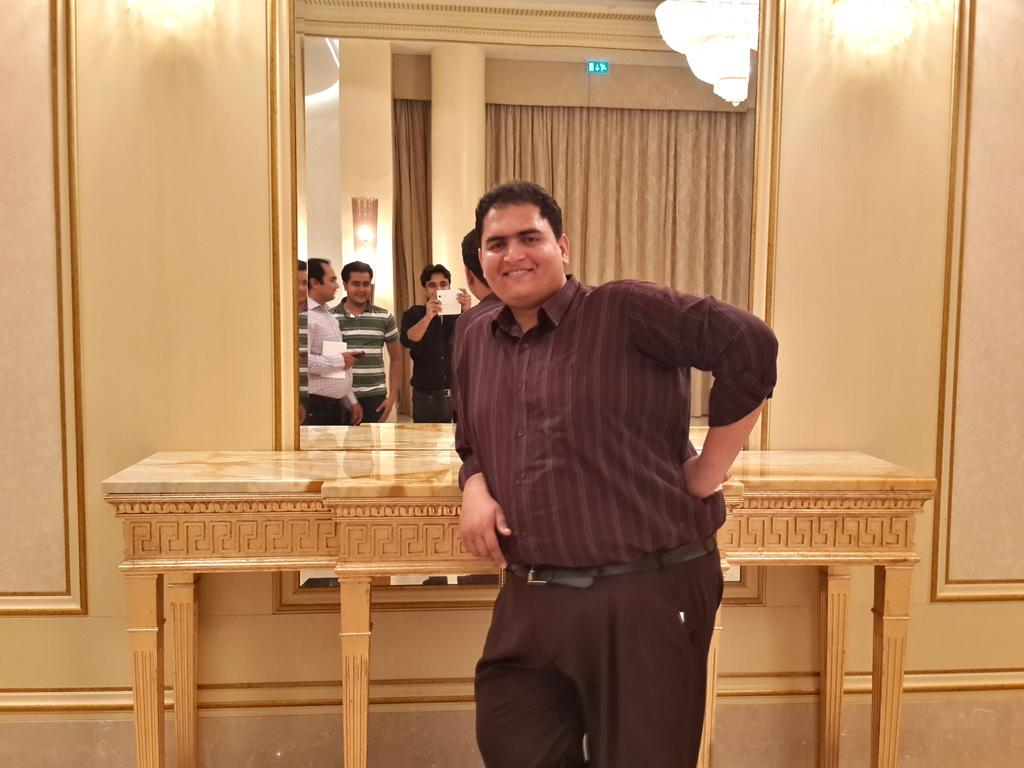What is the main subject of the image? There is a person standing in the image. What object is present in the image that can reflect images? There is a mirror in the image. How many other persons can be seen in the image, considering the reflection in the mirror? There are three other persons visible in the mirror. What type of story is being told by the hydrant in the image? There is no hydrant present in the image, so no story can be told by a hydrant. 